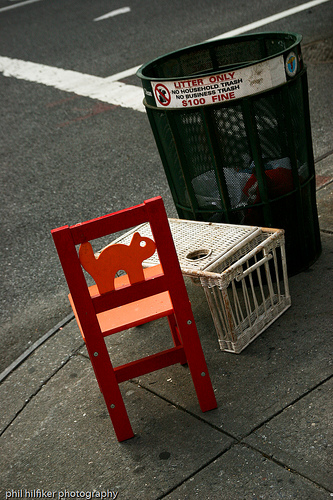<image>
Can you confirm if the cat is in the chair? Yes. The cat is contained within or inside the chair, showing a containment relationship. Where is the chair in relation to the trash can? Is it in the trash can? No. The chair is not contained within the trash can. These objects have a different spatial relationship. 